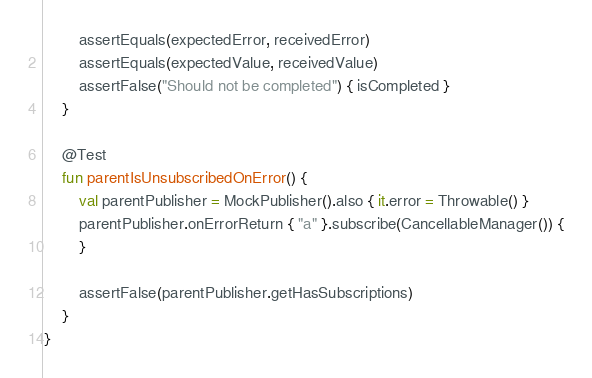<code> <loc_0><loc_0><loc_500><loc_500><_Kotlin_>
        assertEquals(expectedError, receivedError)
        assertEquals(expectedValue, receivedValue)
        assertFalse("Should not be completed") { isCompleted }
    }

    @Test
    fun parentIsUnsubscribedOnError() {
        val parentPublisher = MockPublisher().also { it.error = Throwable() }
        parentPublisher.onErrorReturn { "a" }.subscribe(CancellableManager()) {
        }

        assertFalse(parentPublisher.getHasSubscriptions)
    }
}
</code> 